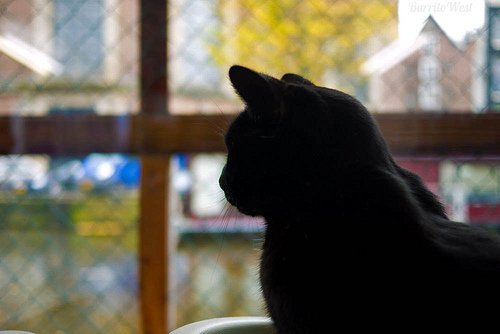<image>
Is there a cat under the window? No. The cat is not positioned under the window. The vertical relationship between these objects is different. 